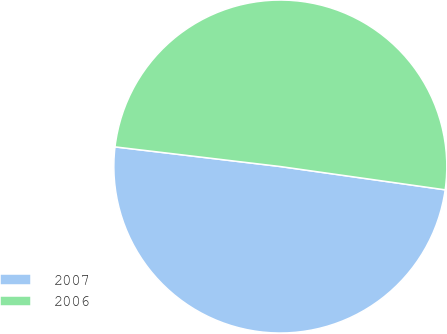<chart> <loc_0><loc_0><loc_500><loc_500><pie_chart><fcel>2007<fcel>2006<nl><fcel>49.65%<fcel>50.35%<nl></chart> 